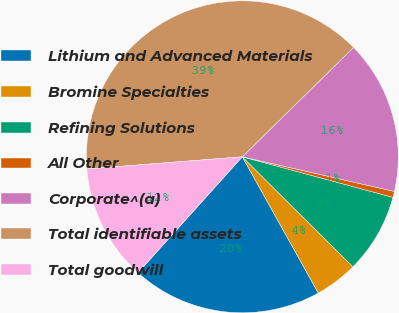Convert chart to OTSL. <chart><loc_0><loc_0><loc_500><loc_500><pie_chart><fcel>Lithium and Advanced Materials<fcel>Bromine Specialties<fcel>Refining Solutions<fcel>All Other<fcel>Corporate^(a)<fcel>Total identifiable assets<fcel>Total goodwill<nl><fcel>19.75%<fcel>4.45%<fcel>8.27%<fcel>0.62%<fcel>15.93%<fcel>38.88%<fcel>12.1%<nl></chart> 